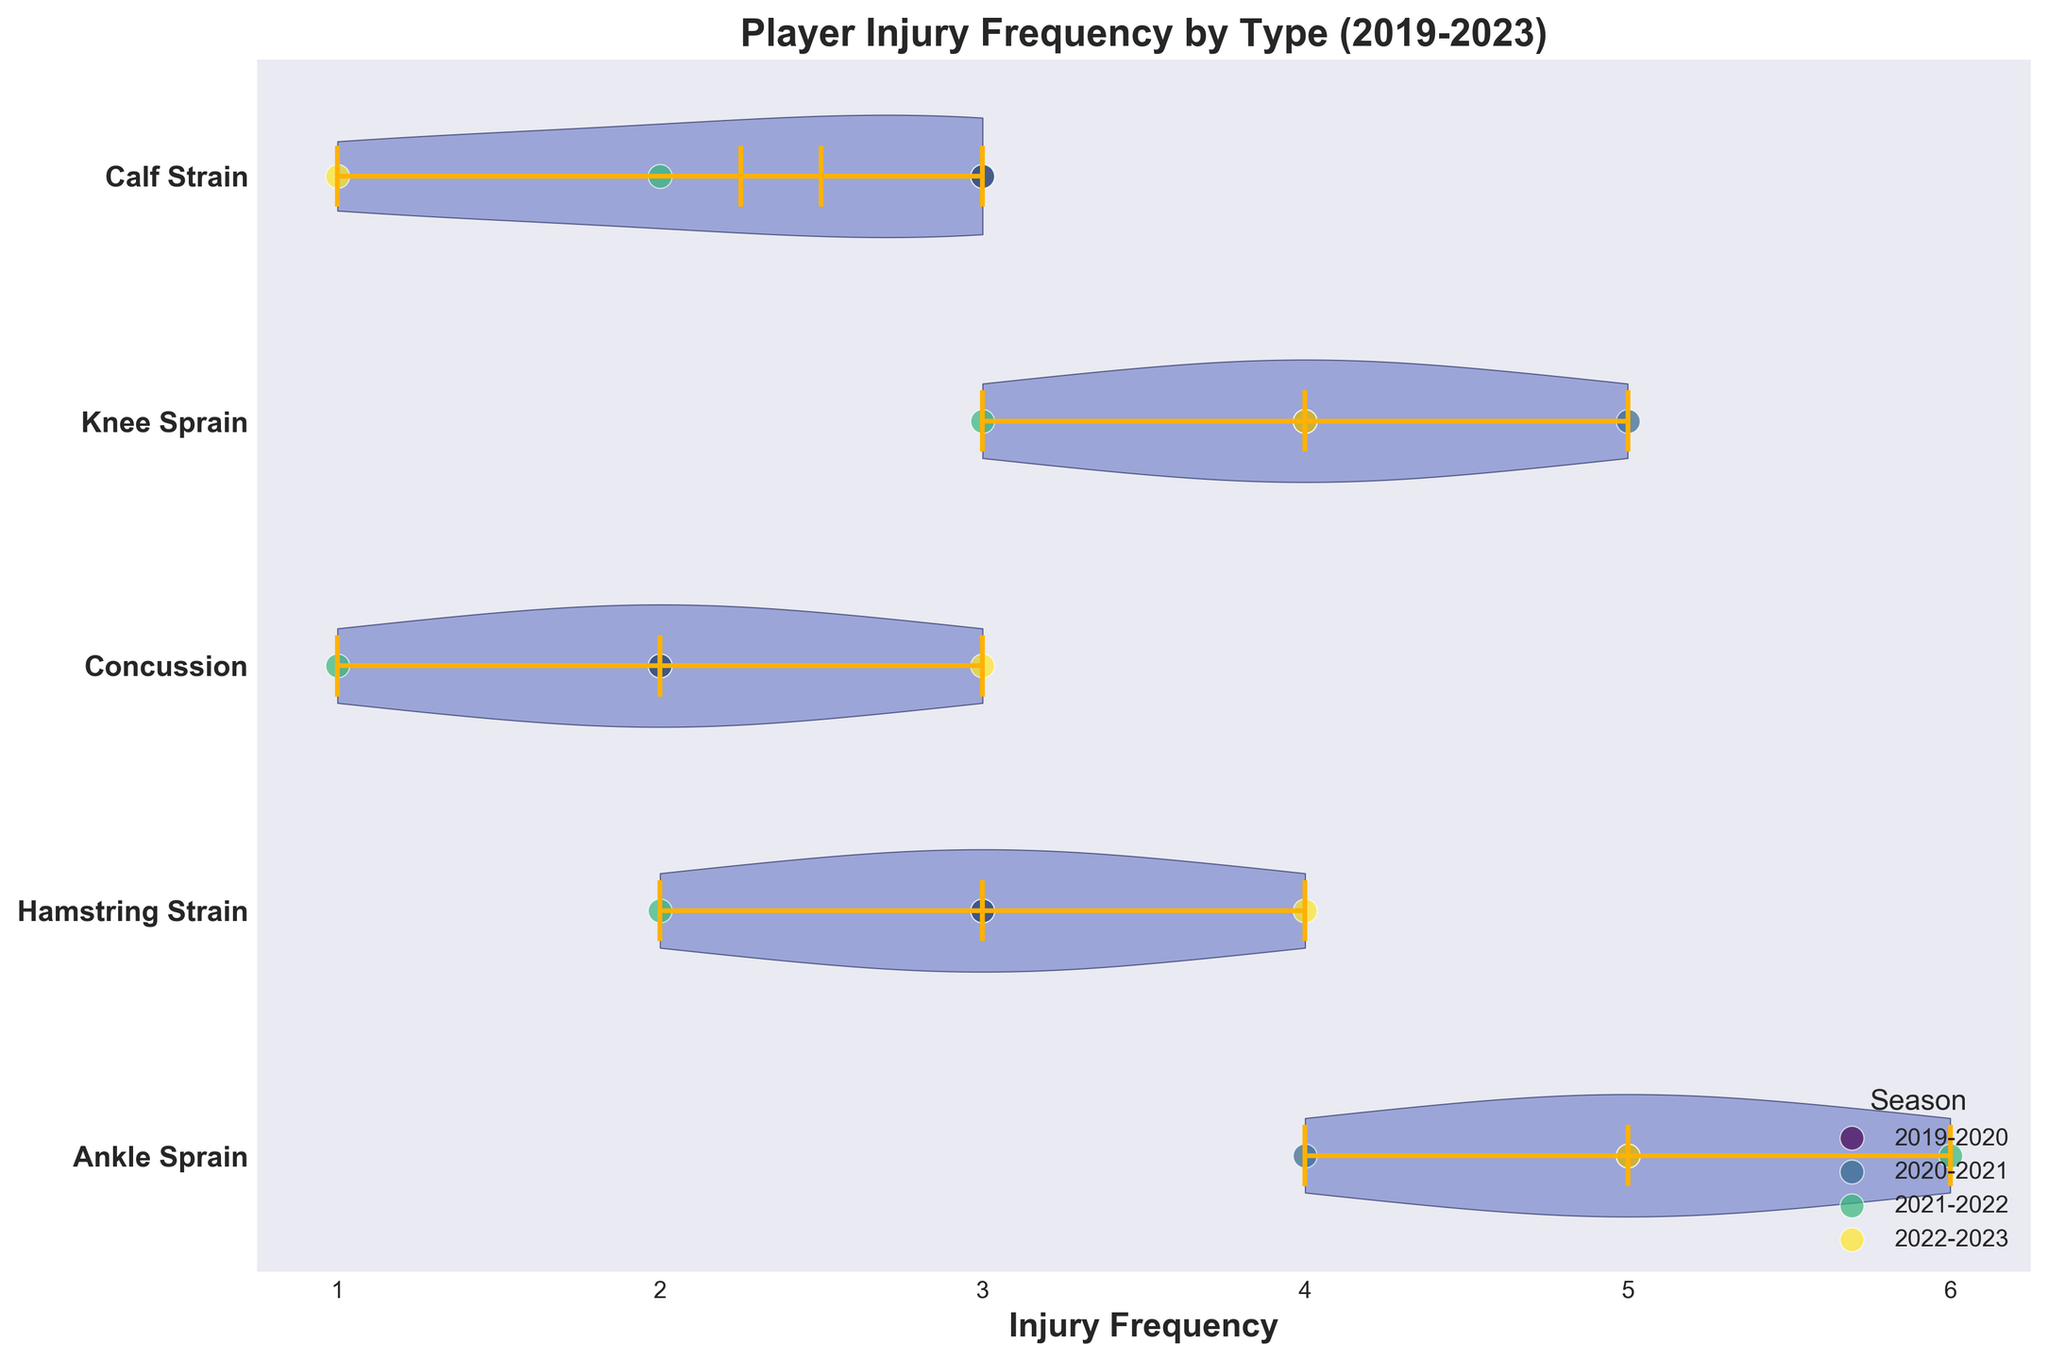Which injury has the highest average frequency? The horizontal violin chart shows the distribution of injury frequencies for each injury type with means indicated. By visually inspecting the mean lines, the Ankle Sprain consistently shows higher average frequencies compared to other injury types.
Answer: Ankle Sprain What is the overall trend in injury frequency from 2019 to 2023 for Knee Sprains? By observing the scatter points for Knee Sprains in different seasons, we see the frequencies are 4, 5, 3, and 4 for 2019-2020, 2020-2021, 2021-2022, and 2022-2023 respectively. It fluctuates without a clear upward or downward trend.
Answer: Fluctuating Which season had the highest frequency of Hamstring Strains? Looking at the scatter plot, the colors corresponding to different seasons show that the highest frequency scatter point for Hamstring Strains is in the 2022-2023 season with a frequency of 4.
Answer: 2022-2023 How does the distribution of Concussions compare to Ankle Sprains over the four seasons? The width of the violin plots, which indicates the spread of data, shows that Concussions have narrower distributions compared to Ankle Sprains, meaning Concussions are less frequent and less variable. Ankle Sprains, on the other hand, have wider violins indicating higher frequency and more variability.
Answer: Less frequent and less variable for Concussions, more frequent and variable for Ankle Sprains Which injury type shows the least variability and how can you tell? Variability can be determined by looking at the width of the violin plots. Calf Strains have the narrowest violin plot, indicating the least variability in injury frequency.
Answer: Calf Strain Between 2019-2020 and 2022-2023, which injury type had the most consistent frequency? By comparing the scatter points for each injury type over the four seasons, Calf Strains have scatter points clustered close together (3, 3, 2, 1), showing the most consistent frequency.
Answer: Calf Strains Which season had the highest total injury frequencies across all types? Add the frequencies for all injuries in each season. For 2019-2020: 5+3+2+4+3 = 17, for 2020-2021: 4+3+2+5+3 = 17, for 2021-2022: 6+2+1+3+2 = 14, for 2022-2023: 5+4+3+4+1 = 17. Three seasons (2019-2020, 2020-2021, and 2022-2023) had the highest total frequencies at 17 each.
Answer: 2019-2020, 2020-2021, and 2022-2023 Which injuries show a marked increase in frequency from one season to another? By comparing scatter points across seasons for each injury type: Ankle Sprains increased from 4 to 6 from 2020-2021 to 2021-2022.
Answer: Ankle Sprains from 2020-2021 to 2021-2022 